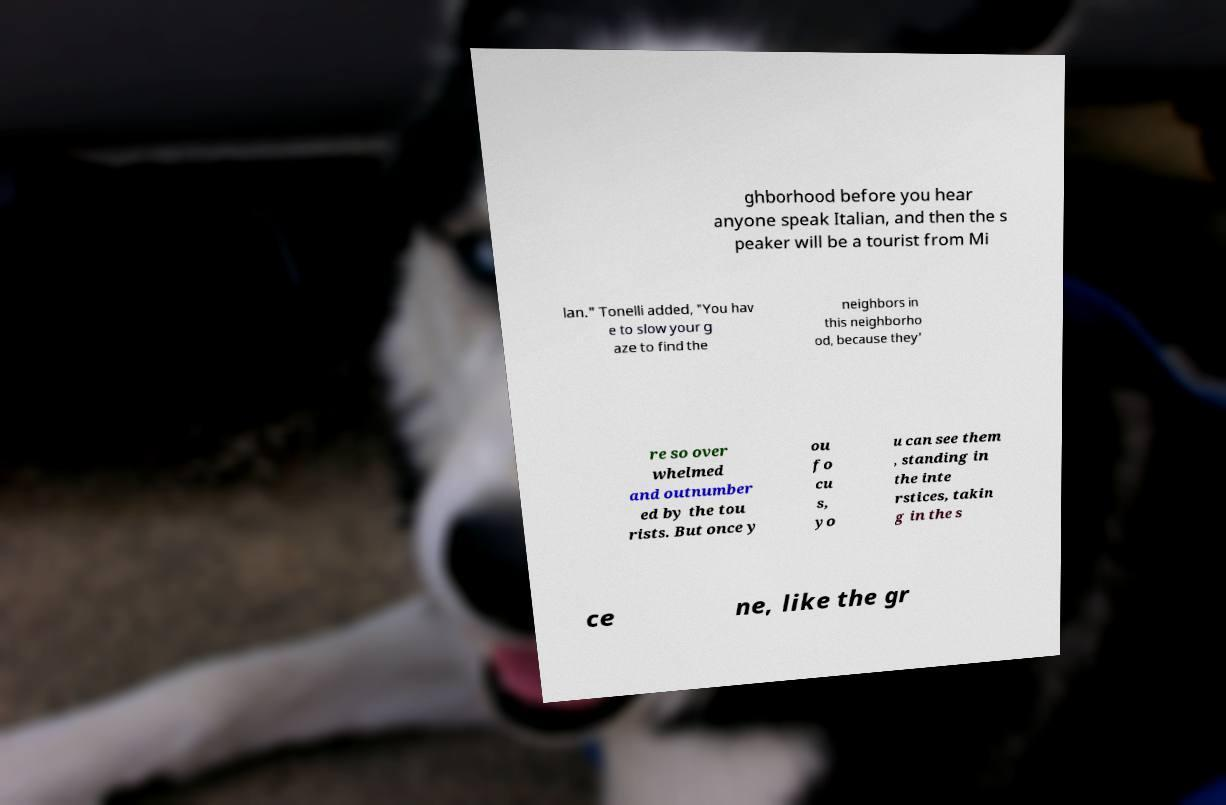Could you extract and type out the text from this image? ghborhood before you hear anyone speak Italian, and then the s peaker will be a tourist from Mi lan." Tonelli added, "You hav e to slow your g aze to find the neighbors in this neighborho od, because they' re so over whelmed and outnumber ed by the tou rists. But once y ou fo cu s, yo u can see them , standing in the inte rstices, takin g in the s ce ne, like the gr 